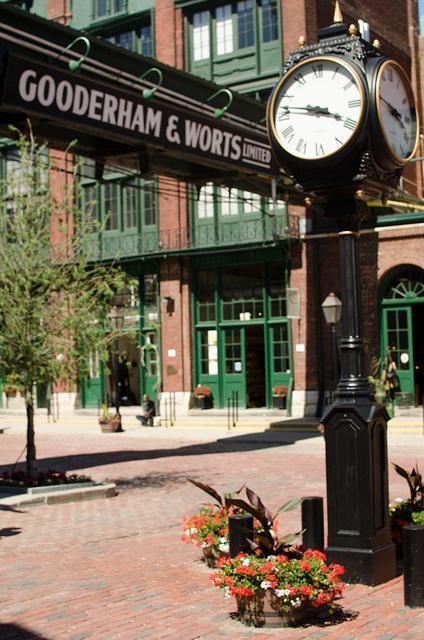How many clocks can you see?
Give a very brief answer. 2. How many potted plants are in the picture?
Give a very brief answer. 2. How many rolls of toilet paper are in the photo?
Give a very brief answer. 0. 